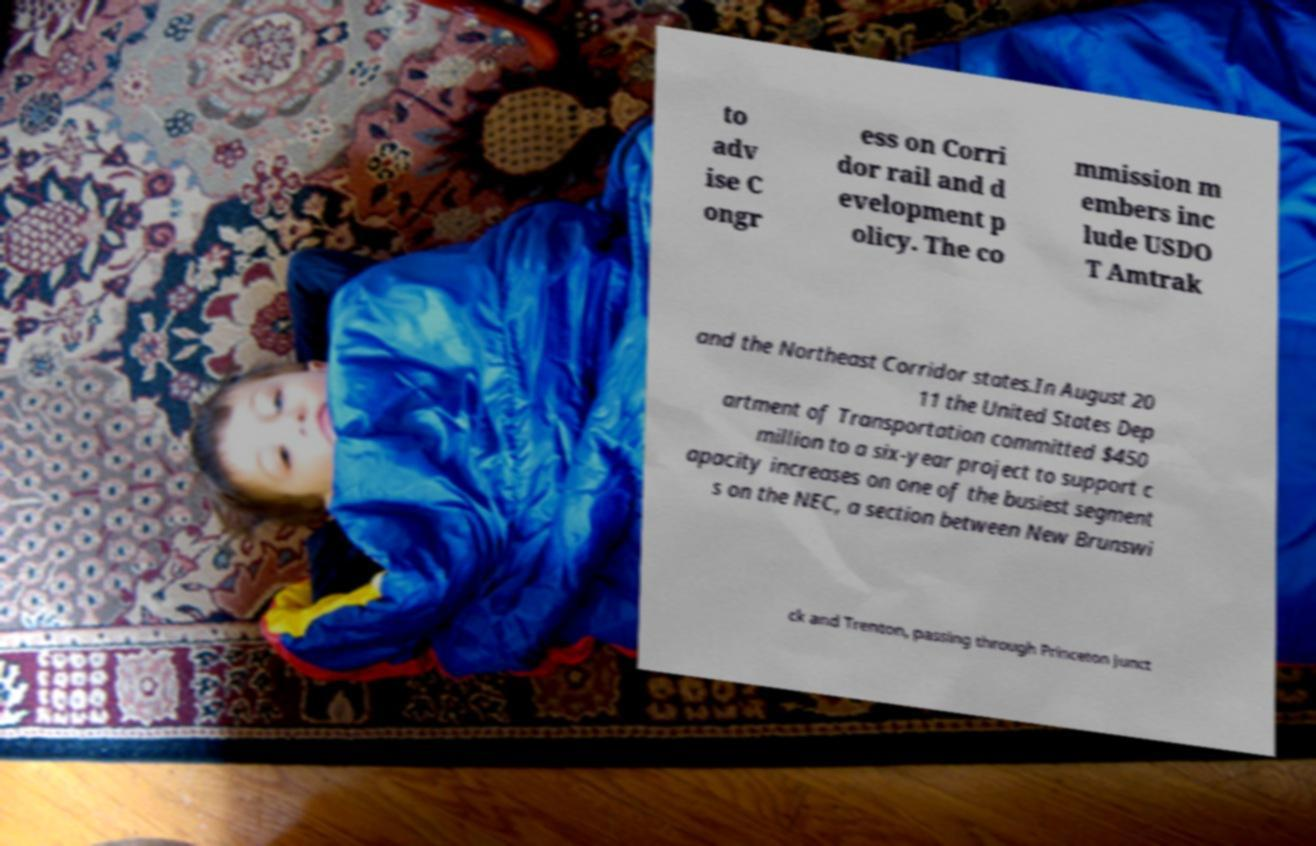I need the written content from this picture converted into text. Can you do that? to adv ise C ongr ess on Corri dor rail and d evelopment p olicy. The co mmission m embers inc lude USDO T Amtrak and the Northeast Corridor states.In August 20 11 the United States Dep artment of Transportation committed $450 million to a six-year project to support c apacity increases on one of the busiest segment s on the NEC, a section between New Brunswi ck and Trenton, passing through Princeton Junct 